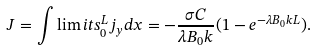<formula> <loc_0><loc_0><loc_500><loc_500>J = \int \lim i t s _ { 0 } ^ { L } j _ { y } d x = - \frac { \sigma C } { \lambda B _ { 0 } k } ( 1 - e ^ { - \lambda B _ { 0 } k L } ) .</formula> 